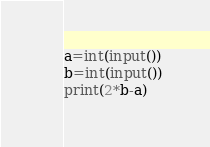Convert code to text. <code><loc_0><loc_0><loc_500><loc_500><_Python_>a=int(input())
b=int(input())
print(2*b-a)</code> 